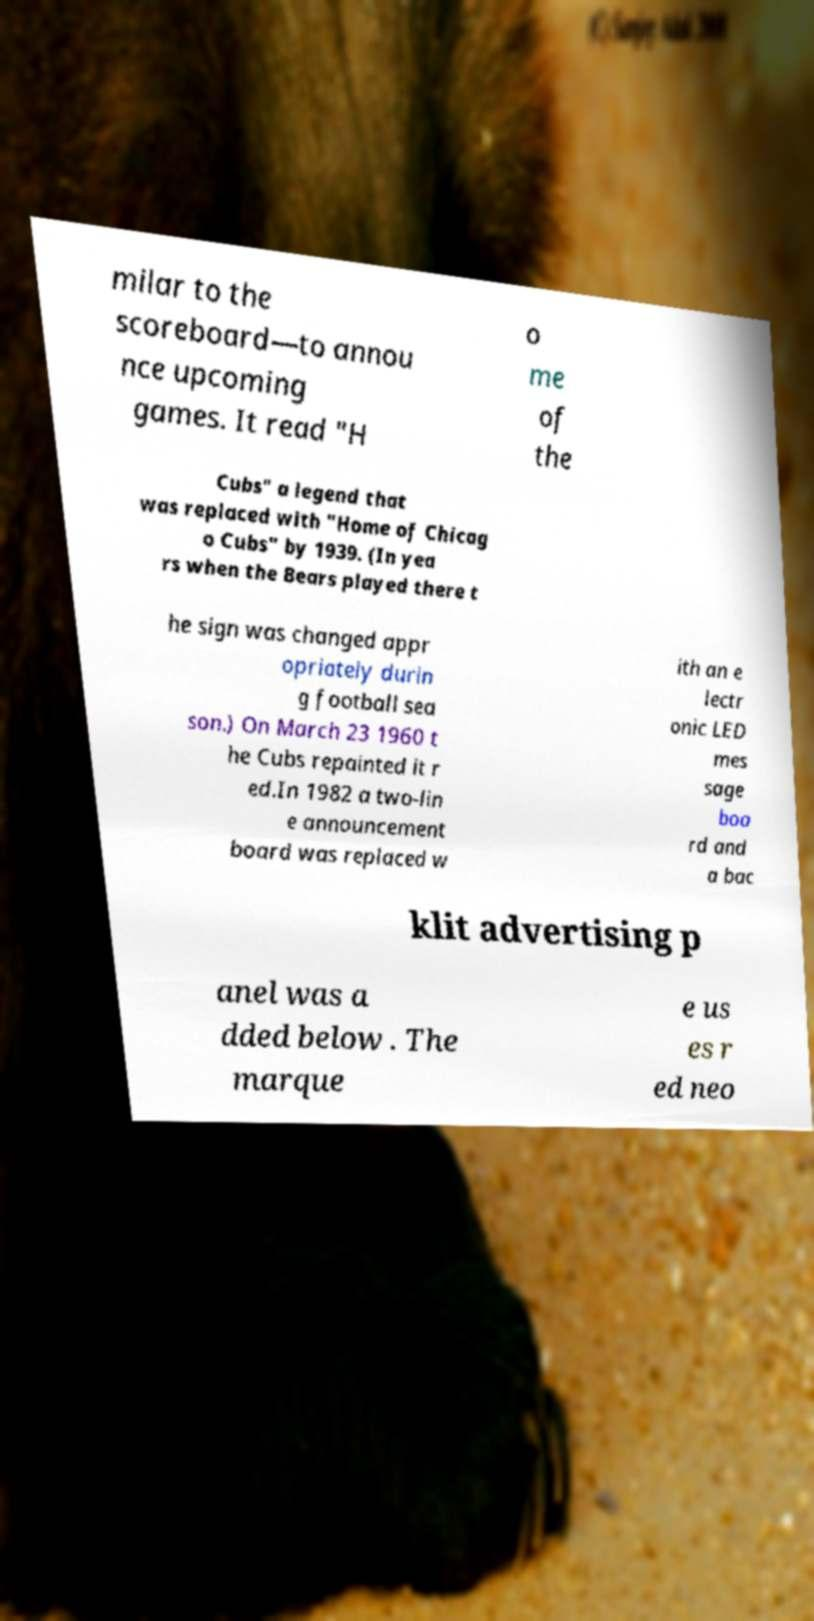Could you extract and type out the text from this image? milar to the scoreboard—to annou nce upcoming games. It read "H o me of the Cubs" a legend that was replaced with "Home of Chicag o Cubs" by 1939. (In yea rs when the Bears played there t he sign was changed appr opriately durin g football sea son.) On March 23 1960 t he Cubs repainted it r ed.In 1982 a two-lin e announcement board was replaced w ith an e lectr onic LED mes sage boa rd and a bac klit advertising p anel was a dded below . The marque e us es r ed neo 